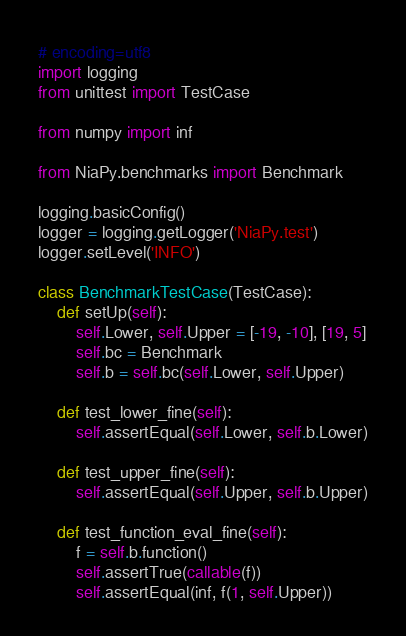Convert code to text. <code><loc_0><loc_0><loc_500><loc_500><_Python_># encoding=utf8
import logging
from unittest import TestCase

from numpy import inf

from NiaPy.benchmarks import Benchmark

logging.basicConfig()
logger = logging.getLogger('NiaPy.test')
logger.setLevel('INFO')

class BenchmarkTestCase(TestCase):
	def setUp(self):
		self.Lower, self.Upper = [-19, -10], [19, 5]
		self.bc = Benchmark
		self.b = self.bc(self.Lower, self.Upper)

	def test_lower_fine(self):
		self.assertEqual(self.Lower, self.b.Lower)

	def test_upper_fine(self):
		self.assertEqual(self.Upper, self.b.Upper)

	def test_function_eval_fine(self):
		f = self.b.function()
		self.assertTrue(callable(f))
		self.assertEqual(inf, f(1, self.Upper))
</code> 